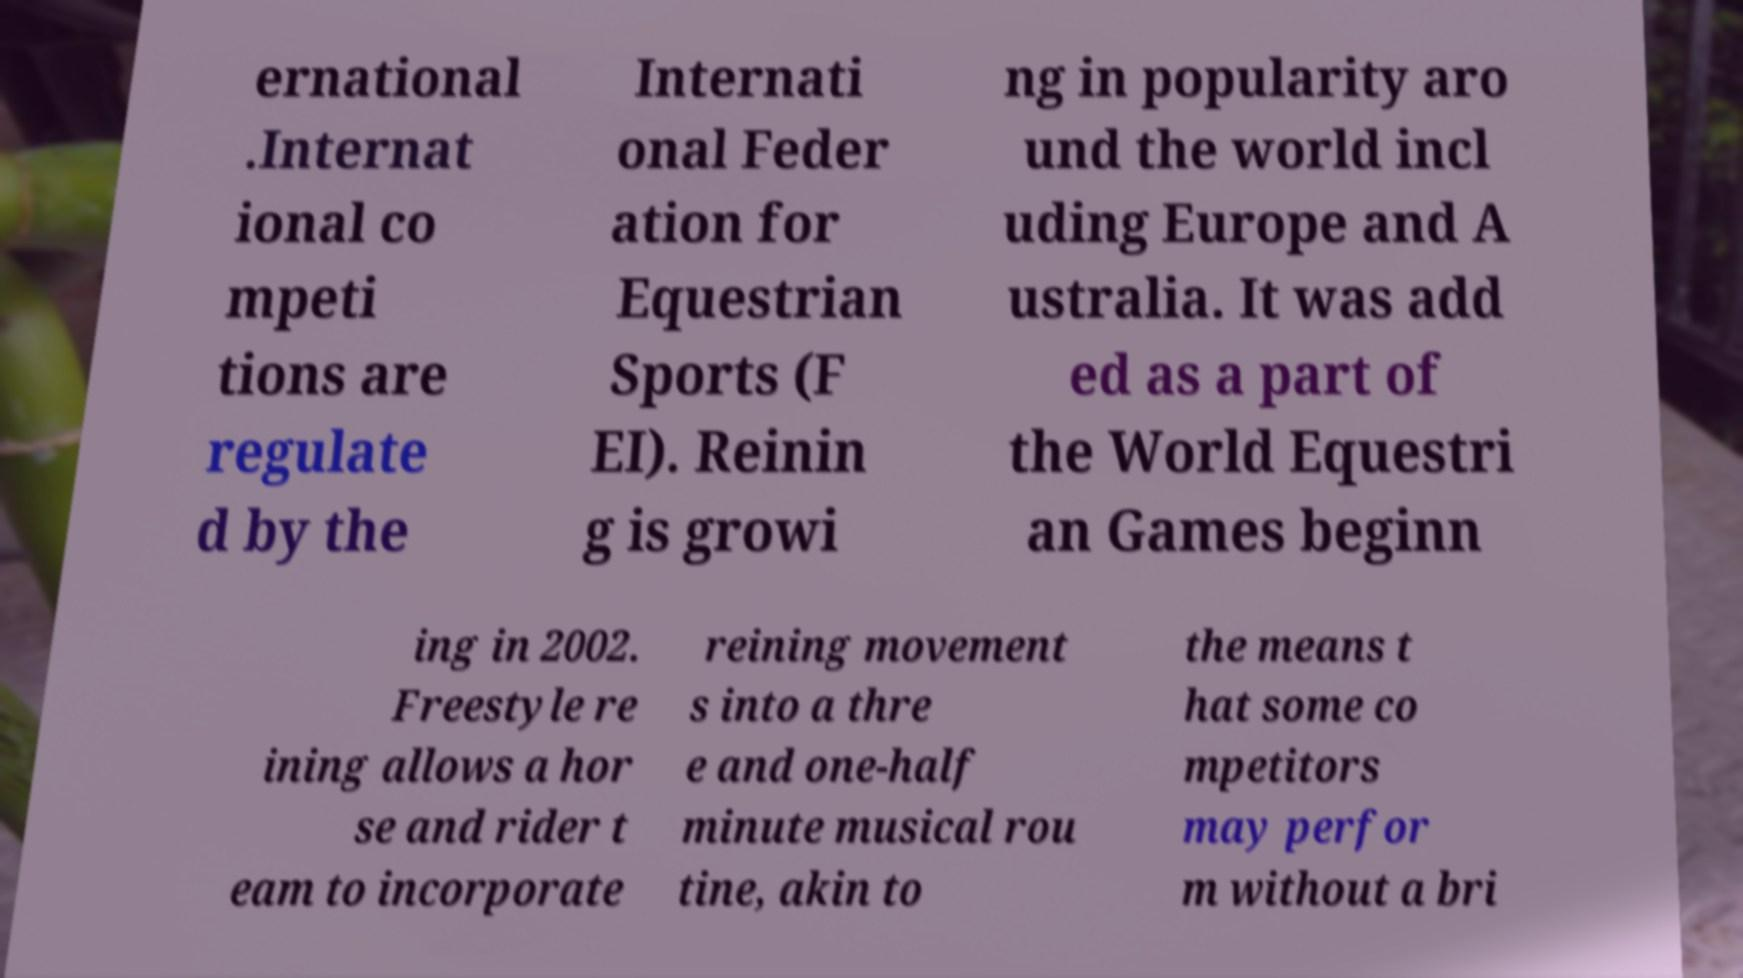For documentation purposes, I need the text within this image transcribed. Could you provide that? ernational .Internat ional co mpeti tions are regulate d by the Internati onal Feder ation for Equestrian Sports (F EI). Reinin g is growi ng in popularity aro und the world incl uding Europe and A ustralia. It was add ed as a part of the World Equestri an Games beginn ing in 2002. Freestyle re ining allows a hor se and rider t eam to incorporate reining movement s into a thre e and one-half minute musical rou tine, akin to the means t hat some co mpetitors may perfor m without a bri 